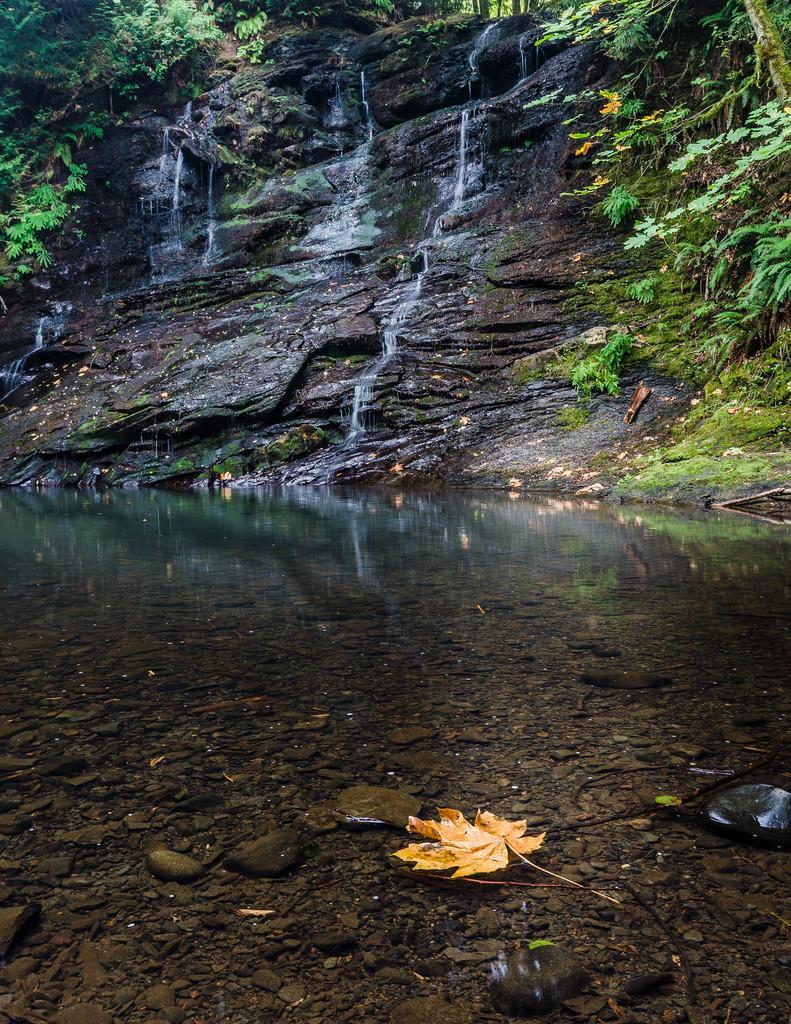Please provide a concise description of this image. In the picture we can see water in the forest near the rock hill, from the rocky hill we can see water falls and beside the hill we can see some plants. 